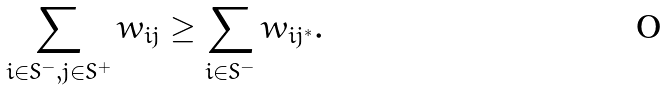<formula> <loc_0><loc_0><loc_500><loc_500>\sum _ { i \in S ^ { - } , j \in S ^ { + } } w _ { i j } \geq \sum _ { i \in S ^ { - } } w _ { i j ^ { * } } .</formula> 